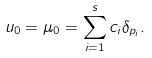Convert formula to latex. <formula><loc_0><loc_0><loc_500><loc_500>u _ { 0 } = \mu _ { 0 } = \sum _ { i = 1 } ^ { s } c _ { i } \delta _ { p _ { i } } .</formula> 